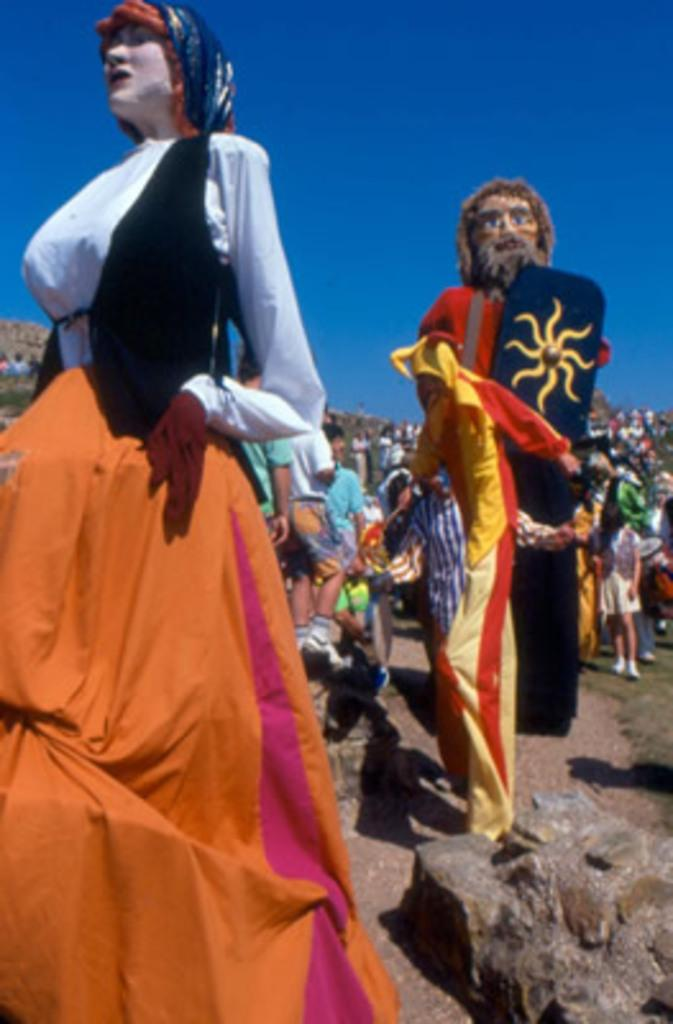How many persons are in the image? There are two persons in the center of the image. What are the persons wearing? The persons are wearing different costumes. What can be seen in the background of the image? There is sky, at least one building, trees, stones, and a group of people in the background of the image. What type of soup is being served in the image? There is no soup present in the image. What type of fruit can be seen hanging from the trees in the background? There is no fruit visible on the trees in the background of the image. 